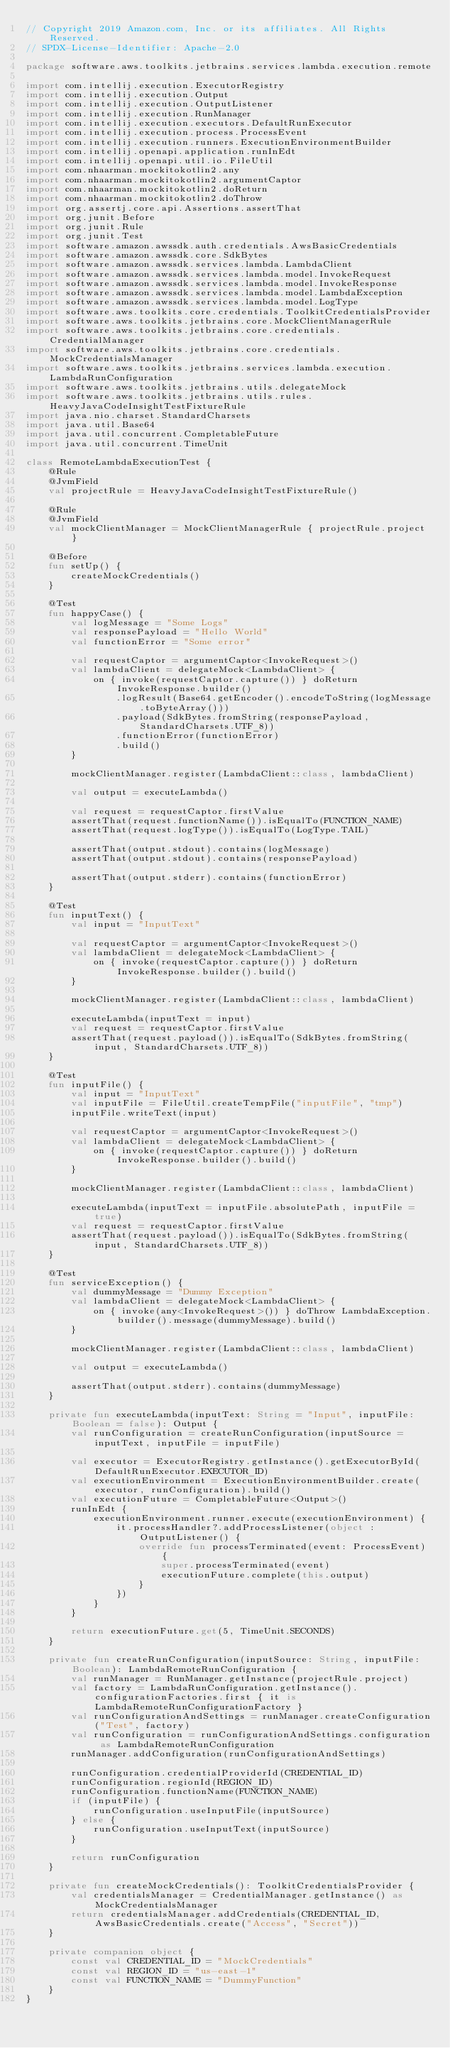Convert code to text. <code><loc_0><loc_0><loc_500><loc_500><_Kotlin_>// Copyright 2019 Amazon.com, Inc. or its affiliates. All Rights Reserved.
// SPDX-License-Identifier: Apache-2.0

package software.aws.toolkits.jetbrains.services.lambda.execution.remote

import com.intellij.execution.ExecutorRegistry
import com.intellij.execution.Output
import com.intellij.execution.OutputListener
import com.intellij.execution.RunManager
import com.intellij.execution.executors.DefaultRunExecutor
import com.intellij.execution.process.ProcessEvent
import com.intellij.execution.runners.ExecutionEnvironmentBuilder
import com.intellij.openapi.application.runInEdt
import com.intellij.openapi.util.io.FileUtil
import com.nhaarman.mockitokotlin2.any
import com.nhaarman.mockitokotlin2.argumentCaptor
import com.nhaarman.mockitokotlin2.doReturn
import com.nhaarman.mockitokotlin2.doThrow
import org.assertj.core.api.Assertions.assertThat
import org.junit.Before
import org.junit.Rule
import org.junit.Test
import software.amazon.awssdk.auth.credentials.AwsBasicCredentials
import software.amazon.awssdk.core.SdkBytes
import software.amazon.awssdk.services.lambda.LambdaClient
import software.amazon.awssdk.services.lambda.model.InvokeRequest
import software.amazon.awssdk.services.lambda.model.InvokeResponse
import software.amazon.awssdk.services.lambda.model.LambdaException
import software.amazon.awssdk.services.lambda.model.LogType
import software.aws.toolkits.core.credentials.ToolkitCredentialsProvider
import software.aws.toolkits.jetbrains.core.MockClientManagerRule
import software.aws.toolkits.jetbrains.core.credentials.CredentialManager
import software.aws.toolkits.jetbrains.core.credentials.MockCredentialsManager
import software.aws.toolkits.jetbrains.services.lambda.execution.LambdaRunConfiguration
import software.aws.toolkits.jetbrains.utils.delegateMock
import software.aws.toolkits.jetbrains.utils.rules.HeavyJavaCodeInsightTestFixtureRule
import java.nio.charset.StandardCharsets
import java.util.Base64
import java.util.concurrent.CompletableFuture
import java.util.concurrent.TimeUnit

class RemoteLambdaExecutionTest {
    @Rule
    @JvmField
    val projectRule = HeavyJavaCodeInsightTestFixtureRule()

    @Rule
    @JvmField
    val mockClientManager = MockClientManagerRule { projectRule.project }

    @Before
    fun setUp() {
        createMockCredentials()
    }

    @Test
    fun happyCase() {
        val logMessage = "Some Logs"
        val responsePayload = "Hello World"
        val functionError = "Some error"

        val requestCaptor = argumentCaptor<InvokeRequest>()
        val lambdaClient = delegateMock<LambdaClient> {
            on { invoke(requestCaptor.capture()) } doReturn InvokeResponse.builder()
                .logResult(Base64.getEncoder().encodeToString(logMessage.toByteArray()))
                .payload(SdkBytes.fromString(responsePayload, StandardCharsets.UTF_8))
                .functionError(functionError)
                .build()
        }

        mockClientManager.register(LambdaClient::class, lambdaClient)

        val output = executeLambda()

        val request = requestCaptor.firstValue
        assertThat(request.functionName()).isEqualTo(FUNCTION_NAME)
        assertThat(request.logType()).isEqualTo(LogType.TAIL)

        assertThat(output.stdout).contains(logMessage)
        assertThat(output.stdout).contains(responsePayload)

        assertThat(output.stderr).contains(functionError)
    }

    @Test
    fun inputText() {
        val input = "InputText"

        val requestCaptor = argumentCaptor<InvokeRequest>()
        val lambdaClient = delegateMock<LambdaClient> {
            on { invoke(requestCaptor.capture()) } doReturn InvokeResponse.builder().build()
        }

        mockClientManager.register(LambdaClient::class, lambdaClient)

        executeLambda(inputText = input)
        val request = requestCaptor.firstValue
        assertThat(request.payload()).isEqualTo(SdkBytes.fromString(input, StandardCharsets.UTF_8))
    }

    @Test
    fun inputFile() {
        val input = "InputText"
        val inputFile = FileUtil.createTempFile("inputFile", "tmp")
        inputFile.writeText(input)

        val requestCaptor = argumentCaptor<InvokeRequest>()
        val lambdaClient = delegateMock<LambdaClient> {
            on { invoke(requestCaptor.capture()) } doReturn InvokeResponse.builder().build()
        }

        mockClientManager.register(LambdaClient::class, lambdaClient)

        executeLambda(inputText = inputFile.absolutePath, inputFile = true)
        val request = requestCaptor.firstValue
        assertThat(request.payload()).isEqualTo(SdkBytes.fromString(input, StandardCharsets.UTF_8))
    }

    @Test
    fun serviceException() {
        val dummyMessage = "Dummy Exception"
        val lambdaClient = delegateMock<LambdaClient> {
            on { invoke(any<InvokeRequest>()) } doThrow LambdaException.builder().message(dummyMessage).build()
        }

        mockClientManager.register(LambdaClient::class, lambdaClient)

        val output = executeLambda()

        assertThat(output.stderr).contains(dummyMessage)
    }

    private fun executeLambda(inputText: String = "Input", inputFile: Boolean = false): Output {
        val runConfiguration = createRunConfiguration(inputSource = inputText, inputFile = inputFile)

        val executor = ExecutorRegistry.getInstance().getExecutorById(DefaultRunExecutor.EXECUTOR_ID)
        val executionEnvironment = ExecutionEnvironmentBuilder.create(executor, runConfiguration).build()
        val executionFuture = CompletableFuture<Output>()
        runInEdt {
            executionEnvironment.runner.execute(executionEnvironment) {
                it.processHandler?.addProcessListener(object : OutputListener() {
                    override fun processTerminated(event: ProcessEvent) {
                        super.processTerminated(event)
                        executionFuture.complete(this.output)
                    }
                })
            }
        }

        return executionFuture.get(5, TimeUnit.SECONDS)
    }

    private fun createRunConfiguration(inputSource: String, inputFile: Boolean): LambdaRemoteRunConfiguration {
        val runManager = RunManager.getInstance(projectRule.project)
        val factory = LambdaRunConfiguration.getInstance().configurationFactories.first { it is LambdaRemoteRunConfigurationFactory }
        val runConfigurationAndSettings = runManager.createConfiguration("Test", factory)
        val runConfiguration = runConfigurationAndSettings.configuration as LambdaRemoteRunConfiguration
        runManager.addConfiguration(runConfigurationAndSettings)

        runConfiguration.credentialProviderId(CREDENTIAL_ID)
        runConfiguration.regionId(REGION_ID)
        runConfiguration.functionName(FUNCTION_NAME)
        if (inputFile) {
            runConfiguration.useInputFile(inputSource)
        } else {
            runConfiguration.useInputText(inputSource)
        }

        return runConfiguration
    }

    private fun createMockCredentials(): ToolkitCredentialsProvider {
        val credentialsManager = CredentialManager.getInstance() as MockCredentialsManager
        return credentialsManager.addCredentials(CREDENTIAL_ID, AwsBasicCredentials.create("Access", "Secret"))
    }

    private companion object {
        const val CREDENTIAL_ID = "MockCredentials"
        const val REGION_ID = "us-east-1"
        const val FUNCTION_NAME = "DummyFunction"
    }
}</code> 